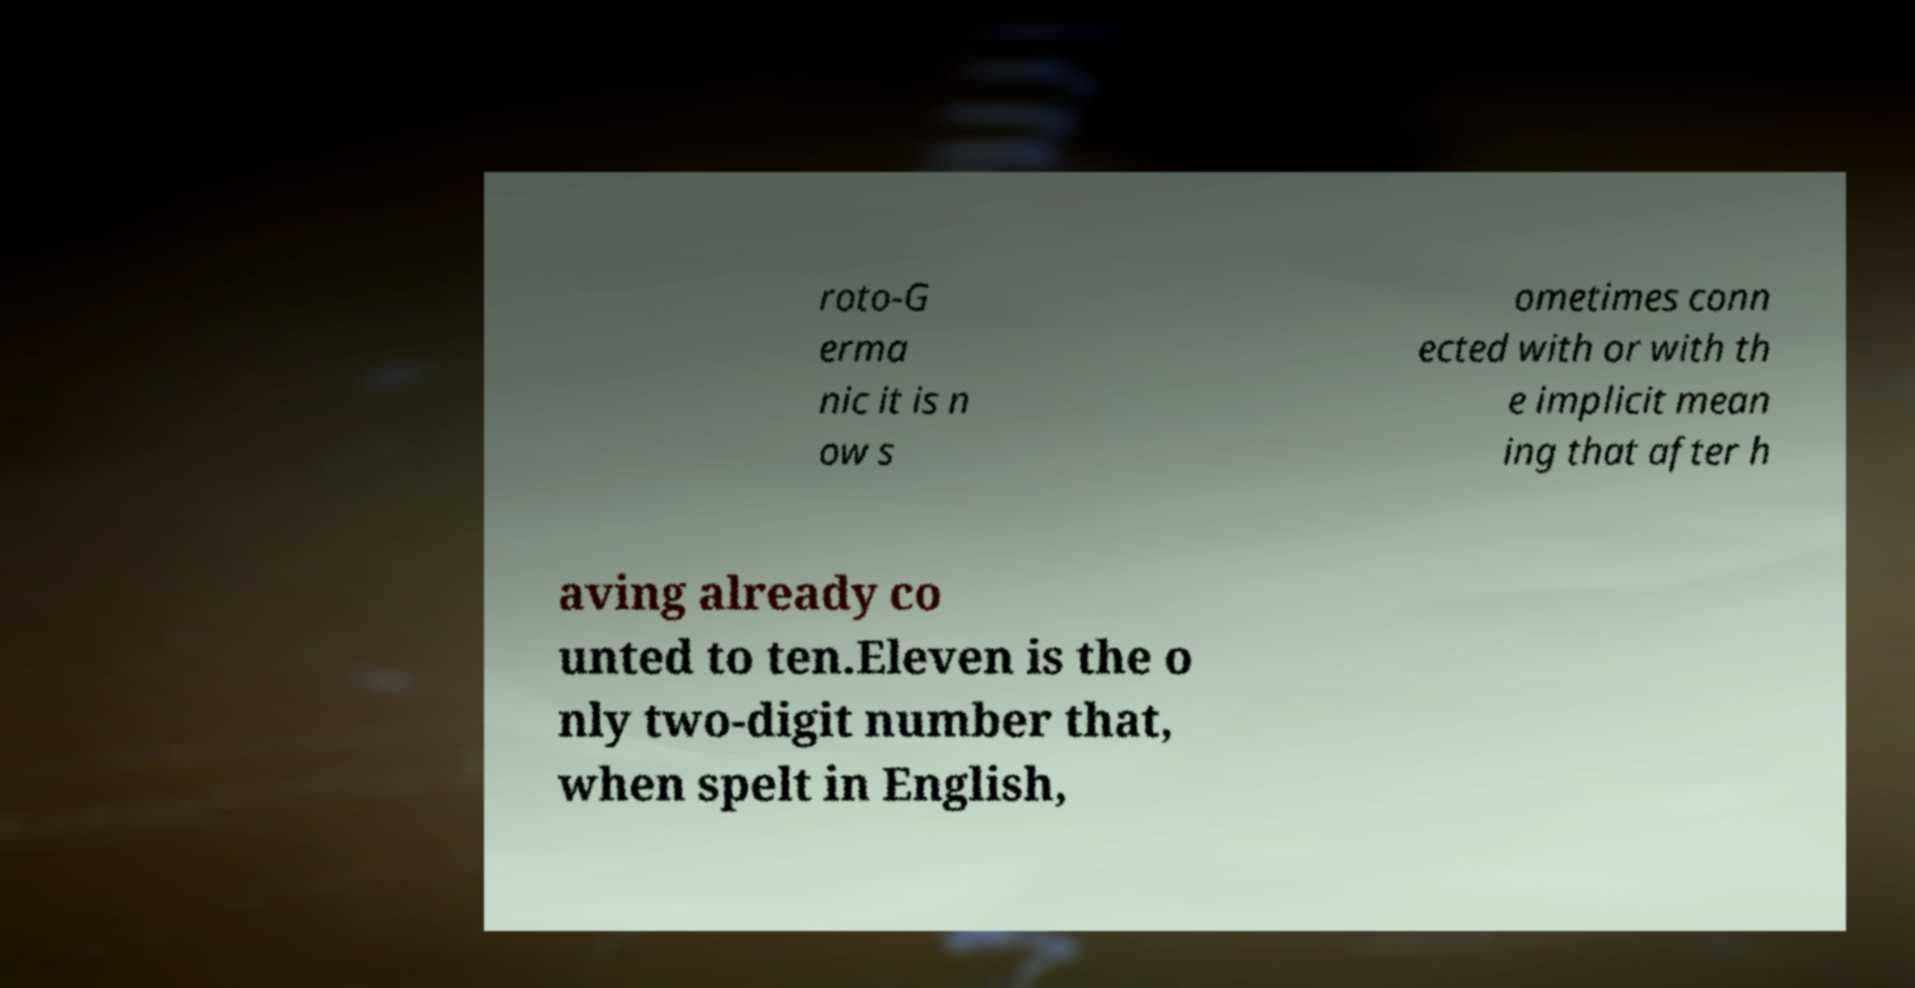Please identify and transcribe the text found in this image. roto-G erma nic it is n ow s ometimes conn ected with or with th e implicit mean ing that after h aving already co unted to ten.Eleven is the o nly two-digit number that, when spelt in English, 